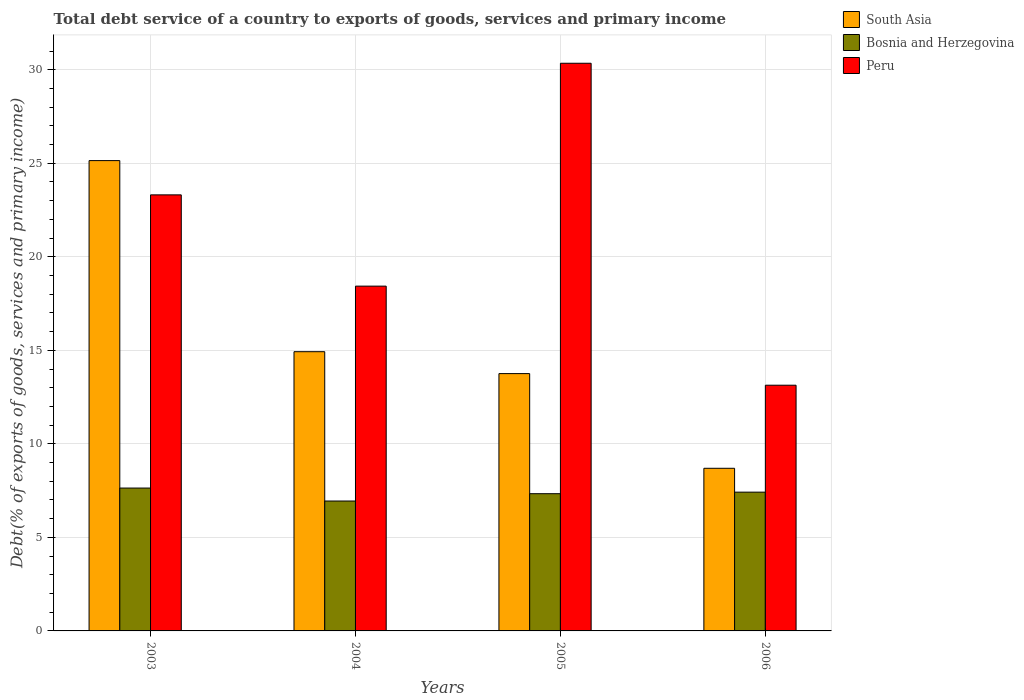How many bars are there on the 4th tick from the left?
Offer a terse response. 3. What is the total debt service in South Asia in 2005?
Your answer should be compact. 13.76. Across all years, what is the maximum total debt service in Bosnia and Herzegovina?
Make the answer very short. 7.64. Across all years, what is the minimum total debt service in Bosnia and Herzegovina?
Make the answer very short. 6.94. In which year was the total debt service in Bosnia and Herzegovina maximum?
Your answer should be very brief. 2003. What is the total total debt service in Peru in the graph?
Offer a very short reply. 85.22. What is the difference between the total debt service in South Asia in 2003 and that in 2004?
Provide a short and direct response. 10.21. What is the difference between the total debt service in Peru in 2003 and the total debt service in Bosnia and Herzegovina in 2004?
Make the answer very short. 16.37. What is the average total debt service in South Asia per year?
Offer a very short reply. 15.63. In the year 2004, what is the difference between the total debt service in Bosnia and Herzegovina and total debt service in Peru?
Make the answer very short. -11.49. In how many years, is the total debt service in Peru greater than 1 %?
Offer a terse response. 4. What is the ratio of the total debt service in Peru in 2003 to that in 2006?
Your response must be concise. 1.77. Is the total debt service in Bosnia and Herzegovina in 2003 less than that in 2005?
Provide a succinct answer. No. What is the difference between the highest and the second highest total debt service in Peru?
Offer a terse response. 7.04. What is the difference between the highest and the lowest total debt service in South Asia?
Make the answer very short. 16.45. In how many years, is the total debt service in Peru greater than the average total debt service in Peru taken over all years?
Your response must be concise. 2. What does the 1st bar from the left in 2005 represents?
Your response must be concise. South Asia. What does the 2nd bar from the right in 2003 represents?
Make the answer very short. Bosnia and Herzegovina. What is the difference between two consecutive major ticks on the Y-axis?
Provide a succinct answer. 5. Are the values on the major ticks of Y-axis written in scientific E-notation?
Keep it short and to the point. No. Does the graph contain any zero values?
Ensure brevity in your answer.  No. Does the graph contain grids?
Provide a succinct answer. Yes. How many legend labels are there?
Your answer should be compact. 3. What is the title of the graph?
Make the answer very short. Total debt service of a country to exports of goods, services and primary income. What is the label or title of the Y-axis?
Ensure brevity in your answer.  Debt(% of exports of goods, services and primary income). What is the Debt(% of exports of goods, services and primary income) of South Asia in 2003?
Offer a terse response. 25.14. What is the Debt(% of exports of goods, services and primary income) of Bosnia and Herzegovina in 2003?
Your answer should be compact. 7.64. What is the Debt(% of exports of goods, services and primary income) in Peru in 2003?
Your response must be concise. 23.31. What is the Debt(% of exports of goods, services and primary income) in South Asia in 2004?
Your answer should be very brief. 14.93. What is the Debt(% of exports of goods, services and primary income) in Bosnia and Herzegovina in 2004?
Your answer should be very brief. 6.94. What is the Debt(% of exports of goods, services and primary income) in Peru in 2004?
Provide a short and direct response. 18.43. What is the Debt(% of exports of goods, services and primary income) in South Asia in 2005?
Give a very brief answer. 13.76. What is the Debt(% of exports of goods, services and primary income) in Bosnia and Herzegovina in 2005?
Provide a short and direct response. 7.34. What is the Debt(% of exports of goods, services and primary income) in Peru in 2005?
Make the answer very short. 30.35. What is the Debt(% of exports of goods, services and primary income) in South Asia in 2006?
Provide a short and direct response. 8.69. What is the Debt(% of exports of goods, services and primary income) of Bosnia and Herzegovina in 2006?
Make the answer very short. 7.42. What is the Debt(% of exports of goods, services and primary income) of Peru in 2006?
Give a very brief answer. 13.13. Across all years, what is the maximum Debt(% of exports of goods, services and primary income) of South Asia?
Offer a very short reply. 25.14. Across all years, what is the maximum Debt(% of exports of goods, services and primary income) in Bosnia and Herzegovina?
Provide a short and direct response. 7.64. Across all years, what is the maximum Debt(% of exports of goods, services and primary income) of Peru?
Your answer should be very brief. 30.35. Across all years, what is the minimum Debt(% of exports of goods, services and primary income) in South Asia?
Your answer should be compact. 8.69. Across all years, what is the minimum Debt(% of exports of goods, services and primary income) in Bosnia and Herzegovina?
Provide a succinct answer. 6.94. Across all years, what is the minimum Debt(% of exports of goods, services and primary income) in Peru?
Provide a short and direct response. 13.13. What is the total Debt(% of exports of goods, services and primary income) in South Asia in the graph?
Your response must be concise. 62.52. What is the total Debt(% of exports of goods, services and primary income) of Bosnia and Herzegovina in the graph?
Give a very brief answer. 29.33. What is the total Debt(% of exports of goods, services and primary income) in Peru in the graph?
Keep it short and to the point. 85.22. What is the difference between the Debt(% of exports of goods, services and primary income) in South Asia in 2003 and that in 2004?
Provide a short and direct response. 10.21. What is the difference between the Debt(% of exports of goods, services and primary income) of Bosnia and Herzegovina in 2003 and that in 2004?
Offer a very short reply. 0.69. What is the difference between the Debt(% of exports of goods, services and primary income) of Peru in 2003 and that in 2004?
Offer a very short reply. 4.88. What is the difference between the Debt(% of exports of goods, services and primary income) of South Asia in 2003 and that in 2005?
Your response must be concise. 11.39. What is the difference between the Debt(% of exports of goods, services and primary income) of Bosnia and Herzegovina in 2003 and that in 2005?
Make the answer very short. 0.3. What is the difference between the Debt(% of exports of goods, services and primary income) in Peru in 2003 and that in 2005?
Your answer should be very brief. -7.04. What is the difference between the Debt(% of exports of goods, services and primary income) of South Asia in 2003 and that in 2006?
Offer a very short reply. 16.45. What is the difference between the Debt(% of exports of goods, services and primary income) in Bosnia and Herzegovina in 2003 and that in 2006?
Provide a succinct answer. 0.22. What is the difference between the Debt(% of exports of goods, services and primary income) of Peru in 2003 and that in 2006?
Keep it short and to the point. 10.18. What is the difference between the Debt(% of exports of goods, services and primary income) in South Asia in 2004 and that in 2005?
Provide a succinct answer. 1.17. What is the difference between the Debt(% of exports of goods, services and primary income) of Bosnia and Herzegovina in 2004 and that in 2005?
Offer a terse response. -0.39. What is the difference between the Debt(% of exports of goods, services and primary income) of Peru in 2004 and that in 2005?
Ensure brevity in your answer.  -11.91. What is the difference between the Debt(% of exports of goods, services and primary income) of South Asia in 2004 and that in 2006?
Ensure brevity in your answer.  6.23. What is the difference between the Debt(% of exports of goods, services and primary income) of Bosnia and Herzegovina in 2004 and that in 2006?
Your answer should be very brief. -0.47. What is the difference between the Debt(% of exports of goods, services and primary income) in Peru in 2004 and that in 2006?
Give a very brief answer. 5.3. What is the difference between the Debt(% of exports of goods, services and primary income) in South Asia in 2005 and that in 2006?
Your answer should be very brief. 5.06. What is the difference between the Debt(% of exports of goods, services and primary income) of Bosnia and Herzegovina in 2005 and that in 2006?
Offer a terse response. -0.08. What is the difference between the Debt(% of exports of goods, services and primary income) of Peru in 2005 and that in 2006?
Ensure brevity in your answer.  17.21. What is the difference between the Debt(% of exports of goods, services and primary income) of South Asia in 2003 and the Debt(% of exports of goods, services and primary income) of Bosnia and Herzegovina in 2004?
Your answer should be compact. 18.2. What is the difference between the Debt(% of exports of goods, services and primary income) of South Asia in 2003 and the Debt(% of exports of goods, services and primary income) of Peru in 2004?
Make the answer very short. 6.71. What is the difference between the Debt(% of exports of goods, services and primary income) in Bosnia and Herzegovina in 2003 and the Debt(% of exports of goods, services and primary income) in Peru in 2004?
Give a very brief answer. -10.79. What is the difference between the Debt(% of exports of goods, services and primary income) of South Asia in 2003 and the Debt(% of exports of goods, services and primary income) of Bosnia and Herzegovina in 2005?
Your answer should be compact. 17.81. What is the difference between the Debt(% of exports of goods, services and primary income) of South Asia in 2003 and the Debt(% of exports of goods, services and primary income) of Peru in 2005?
Provide a succinct answer. -5.2. What is the difference between the Debt(% of exports of goods, services and primary income) of Bosnia and Herzegovina in 2003 and the Debt(% of exports of goods, services and primary income) of Peru in 2005?
Provide a succinct answer. -22.71. What is the difference between the Debt(% of exports of goods, services and primary income) in South Asia in 2003 and the Debt(% of exports of goods, services and primary income) in Bosnia and Herzegovina in 2006?
Your answer should be very brief. 17.72. What is the difference between the Debt(% of exports of goods, services and primary income) in South Asia in 2003 and the Debt(% of exports of goods, services and primary income) in Peru in 2006?
Your response must be concise. 12.01. What is the difference between the Debt(% of exports of goods, services and primary income) in Bosnia and Herzegovina in 2003 and the Debt(% of exports of goods, services and primary income) in Peru in 2006?
Make the answer very short. -5.5. What is the difference between the Debt(% of exports of goods, services and primary income) of South Asia in 2004 and the Debt(% of exports of goods, services and primary income) of Bosnia and Herzegovina in 2005?
Your answer should be very brief. 7.59. What is the difference between the Debt(% of exports of goods, services and primary income) of South Asia in 2004 and the Debt(% of exports of goods, services and primary income) of Peru in 2005?
Your response must be concise. -15.42. What is the difference between the Debt(% of exports of goods, services and primary income) of Bosnia and Herzegovina in 2004 and the Debt(% of exports of goods, services and primary income) of Peru in 2005?
Make the answer very short. -23.4. What is the difference between the Debt(% of exports of goods, services and primary income) in South Asia in 2004 and the Debt(% of exports of goods, services and primary income) in Bosnia and Herzegovina in 2006?
Provide a succinct answer. 7.51. What is the difference between the Debt(% of exports of goods, services and primary income) in South Asia in 2004 and the Debt(% of exports of goods, services and primary income) in Peru in 2006?
Keep it short and to the point. 1.79. What is the difference between the Debt(% of exports of goods, services and primary income) in Bosnia and Herzegovina in 2004 and the Debt(% of exports of goods, services and primary income) in Peru in 2006?
Offer a very short reply. -6.19. What is the difference between the Debt(% of exports of goods, services and primary income) of South Asia in 2005 and the Debt(% of exports of goods, services and primary income) of Bosnia and Herzegovina in 2006?
Provide a succinct answer. 6.34. What is the difference between the Debt(% of exports of goods, services and primary income) in South Asia in 2005 and the Debt(% of exports of goods, services and primary income) in Peru in 2006?
Keep it short and to the point. 0.62. What is the difference between the Debt(% of exports of goods, services and primary income) of Bosnia and Herzegovina in 2005 and the Debt(% of exports of goods, services and primary income) of Peru in 2006?
Provide a succinct answer. -5.8. What is the average Debt(% of exports of goods, services and primary income) of South Asia per year?
Ensure brevity in your answer.  15.63. What is the average Debt(% of exports of goods, services and primary income) of Bosnia and Herzegovina per year?
Offer a very short reply. 7.33. What is the average Debt(% of exports of goods, services and primary income) in Peru per year?
Keep it short and to the point. 21.31. In the year 2003, what is the difference between the Debt(% of exports of goods, services and primary income) in South Asia and Debt(% of exports of goods, services and primary income) in Bosnia and Herzegovina?
Keep it short and to the point. 17.5. In the year 2003, what is the difference between the Debt(% of exports of goods, services and primary income) of South Asia and Debt(% of exports of goods, services and primary income) of Peru?
Provide a succinct answer. 1.83. In the year 2003, what is the difference between the Debt(% of exports of goods, services and primary income) of Bosnia and Herzegovina and Debt(% of exports of goods, services and primary income) of Peru?
Offer a very short reply. -15.67. In the year 2004, what is the difference between the Debt(% of exports of goods, services and primary income) in South Asia and Debt(% of exports of goods, services and primary income) in Bosnia and Herzegovina?
Make the answer very short. 7.98. In the year 2004, what is the difference between the Debt(% of exports of goods, services and primary income) of South Asia and Debt(% of exports of goods, services and primary income) of Peru?
Make the answer very short. -3.5. In the year 2004, what is the difference between the Debt(% of exports of goods, services and primary income) in Bosnia and Herzegovina and Debt(% of exports of goods, services and primary income) in Peru?
Provide a succinct answer. -11.49. In the year 2005, what is the difference between the Debt(% of exports of goods, services and primary income) in South Asia and Debt(% of exports of goods, services and primary income) in Bosnia and Herzegovina?
Your answer should be very brief. 6.42. In the year 2005, what is the difference between the Debt(% of exports of goods, services and primary income) of South Asia and Debt(% of exports of goods, services and primary income) of Peru?
Give a very brief answer. -16.59. In the year 2005, what is the difference between the Debt(% of exports of goods, services and primary income) of Bosnia and Herzegovina and Debt(% of exports of goods, services and primary income) of Peru?
Your answer should be very brief. -23.01. In the year 2006, what is the difference between the Debt(% of exports of goods, services and primary income) in South Asia and Debt(% of exports of goods, services and primary income) in Bosnia and Herzegovina?
Your answer should be very brief. 1.27. In the year 2006, what is the difference between the Debt(% of exports of goods, services and primary income) of South Asia and Debt(% of exports of goods, services and primary income) of Peru?
Your response must be concise. -4.44. In the year 2006, what is the difference between the Debt(% of exports of goods, services and primary income) of Bosnia and Herzegovina and Debt(% of exports of goods, services and primary income) of Peru?
Provide a short and direct response. -5.72. What is the ratio of the Debt(% of exports of goods, services and primary income) in South Asia in 2003 to that in 2004?
Your answer should be compact. 1.68. What is the ratio of the Debt(% of exports of goods, services and primary income) in Bosnia and Herzegovina in 2003 to that in 2004?
Give a very brief answer. 1.1. What is the ratio of the Debt(% of exports of goods, services and primary income) in Peru in 2003 to that in 2004?
Make the answer very short. 1.26. What is the ratio of the Debt(% of exports of goods, services and primary income) of South Asia in 2003 to that in 2005?
Your response must be concise. 1.83. What is the ratio of the Debt(% of exports of goods, services and primary income) in Bosnia and Herzegovina in 2003 to that in 2005?
Provide a succinct answer. 1.04. What is the ratio of the Debt(% of exports of goods, services and primary income) of Peru in 2003 to that in 2005?
Provide a short and direct response. 0.77. What is the ratio of the Debt(% of exports of goods, services and primary income) of South Asia in 2003 to that in 2006?
Your answer should be very brief. 2.89. What is the ratio of the Debt(% of exports of goods, services and primary income) of Bosnia and Herzegovina in 2003 to that in 2006?
Keep it short and to the point. 1.03. What is the ratio of the Debt(% of exports of goods, services and primary income) of Peru in 2003 to that in 2006?
Provide a succinct answer. 1.77. What is the ratio of the Debt(% of exports of goods, services and primary income) of South Asia in 2004 to that in 2005?
Your response must be concise. 1.09. What is the ratio of the Debt(% of exports of goods, services and primary income) in Bosnia and Herzegovina in 2004 to that in 2005?
Offer a very short reply. 0.95. What is the ratio of the Debt(% of exports of goods, services and primary income) in Peru in 2004 to that in 2005?
Offer a very short reply. 0.61. What is the ratio of the Debt(% of exports of goods, services and primary income) of South Asia in 2004 to that in 2006?
Offer a terse response. 1.72. What is the ratio of the Debt(% of exports of goods, services and primary income) of Bosnia and Herzegovina in 2004 to that in 2006?
Provide a succinct answer. 0.94. What is the ratio of the Debt(% of exports of goods, services and primary income) in Peru in 2004 to that in 2006?
Your answer should be compact. 1.4. What is the ratio of the Debt(% of exports of goods, services and primary income) of South Asia in 2005 to that in 2006?
Provide a short and direct response. 1.58. What is the ratio of the Debt(% of exports of goods, services and primary income) of Peru in 2005 to that in 2006?
Make the answer very short. 2.31. What is the difference between the highest and the second highest Debt(% of exports of goods, services and primary income) in South Asia?
Your answer should be very brief. 10.21. What is the difference between the highest and the second highest Debt(% of exports of goods, services and primary income) of Bosnia and Herzegovina?
Your answer should be compact. 0.22. What is the difference between the highest and the second highest Debt(% of exports of goods, services and primary income) in Peru?
Offer a very short reply. 7.04. What is the difference between the highest and the lowest Debt(% of exports of goods, services and primary income) in South Asia?
Offer a terse response. 16.45. What is the difference between the highest and the lowest Debt(% of exports of goods, services and primary income) in Bosnia and Herzegovina?
Your answer should be very brief. 0.69. What is the difference between the highest and the lowest Debt(% of exports of goods, services and primary income) of Peru?
Your response must be concise. 17.21. 